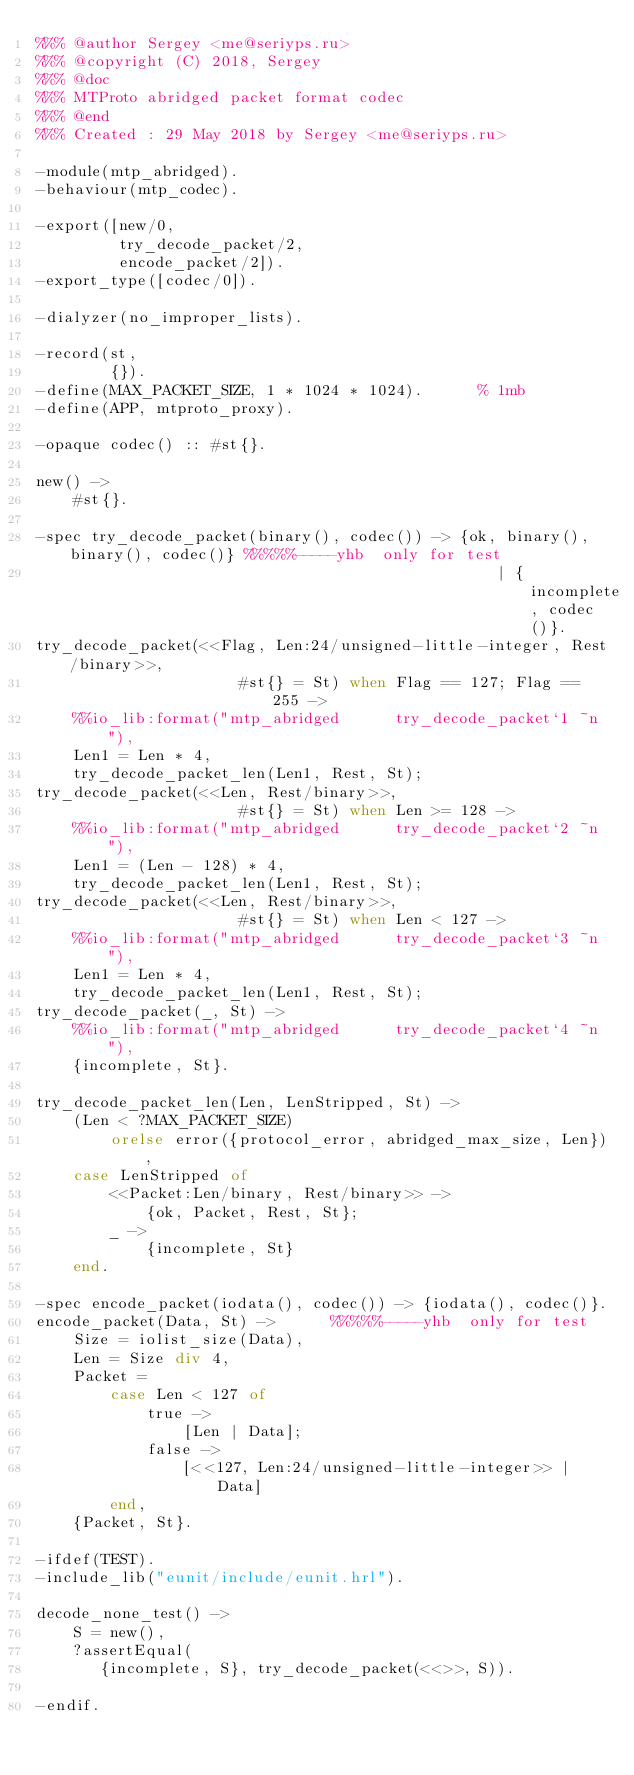Convert code to text. <code><loc_0><loc_0><loc_500><loc_500><_Erlang_>%%% @author Sergey <me@seriyps.ru>
%%% @copyright (C) 2018, Sergey
%%% @doc
%%% MTProto abridged packet format codec
%%% @end
%%% Created : 29 May 2018 by Sergey <me@seriyps.ru>

-module(mtp_abridged).
-behaviour(mtp_codec).

-export([new/0,
         try_decode_packet/2,
         encode_packet/2]).
-export_type([codec/0]).

-dialyzer(no_improper_lists).

-record(st,
        {}).
-define(MAX_PACKET_SIZE, 1 * 1024 * 1024).      % 1mb
-define(APP, mtproto_proxy).

-opaque codec() :: #st{}.

new() ->
    #st{}.

-spec try_decode_packet(binary(), codec()) -> {ok, binary(), binary(), codec()} %%%%%-----yhb  only for test
                                                  | {incomplete, codec()}.
try_decode_packet(<<Flag, Len:24/unsigned-little-integer, Rest/binary>>,
                      #st{} = St) when Flag == 127; Flag == 255 ->
    %%io_lib:format("mtp_abridged      try_decode_packet`1 ~n"),
    Len1 = Len * 4,
    try_decode_packet_len(Len1, Rest, St);
try_decode_packet(<<Len, Rest/binary>>,
                      #st{} = St) when Len >= 128 ->
    %%io_lib:format("mtp_abridged      try_decode_packet`2 ~n"),
    Len1 = (Len - 128) * 4,
    try_decode_packet_len(Len1, Rest, St);
try_decode_packet(<<Len, Rest/binary>>,
                      #st{} = St) when Len < 127 ->
    %%io_lib:format("mtp_abridged      try_decode_packet`3 ~n"),
    Len1 = Len * 4,
    try_decode_packet_len(Len1, Rest, St);
try_decode_packet(_, St) ->
    %%io_lib:format("mtp_abridged      try_decode_packet`4 ~n"),
    {incomplete, St}.

try_decode_packet_len(Len, LenStripped, St) ->
    (Len < ?MAX_PACKET_SIZE)
        orelse error({protocol_error, abridged_max_size, Len}),
    case LenStripped of
        <<Packet:Len/binary, Rest/binary>> ->
            {ok, Packet, Rest, St};
        _ ->
            {incomplete, St}
    end.

-spec encode_packet(iodata(), codec()) -> {iodata(), codec()}.
encode_packet(Data, St) ->      %%%%%-----yhb  only for test
    Size = iolist_size(Data),
    Len = Size div 4,
    Packet =
        case Len < 127 of
            true ->
                [Len | Data];
            false ->
                [<<127, Len:24/unsigned-little-integer>> | Data]
        end,
    {Packet, St}.

-ifdef(TEST).
-include_lib("eunit/include/eunit.hrl").

decode_none_test() ->
    S = new(),
    ?assertEqual(
       {incomplete, S}, try_decode_packet(<<>>, S)).

-endif.
</code> 